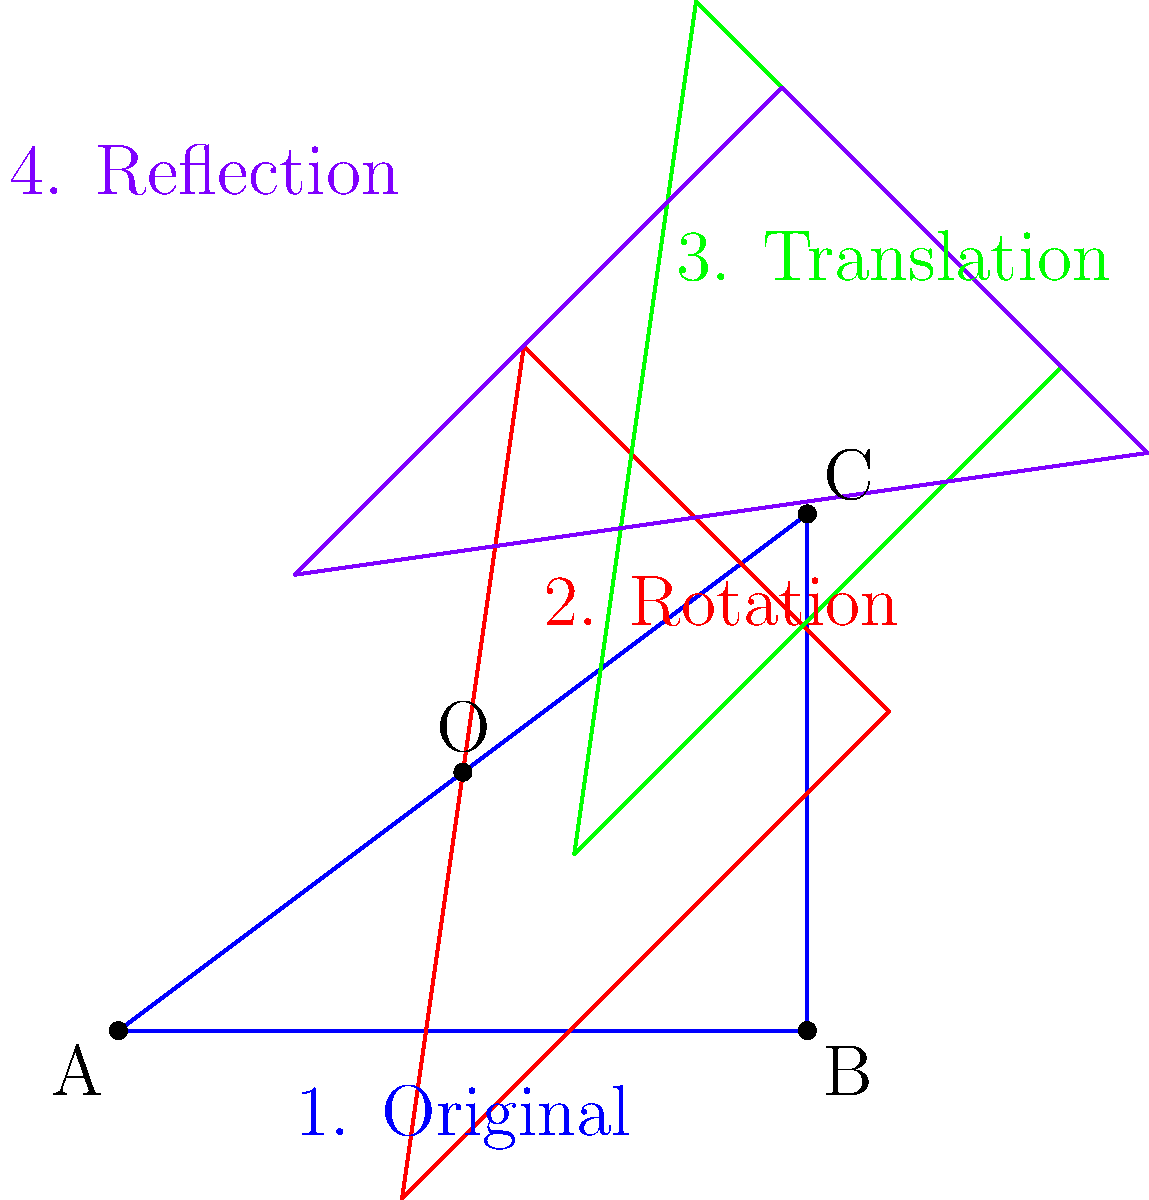Given a triangle ABC with vertices A(0,0), B(4,0), and C(4,3), the following transformations are applied in order:
1. Rotation by 45° counterclockwise around point O(2,1.5)
2. Translation by vector (1,2)
3. Reflection across the line y = x

What are the coordinates of vertex C after all transformations have been applied? Let's break this down step-by-step:

1. Rotation:
   The rotation matrix for 45° counterclockwise is:
   $$R = \begin{bmatrix} \cos 45° & -\sin 45° \\ \sin 45° & \cos 45° \end{bmatrix} = \begin{bmatrix} \frac{\sqrt{2}}{2} & -\frac{\sqrt{2}}{2} \\ \frac{\sqrt{2}}{2} & \frac{\sqrt{2}}{2} \end{bmatrix}$$
   
   First, translate C to origin by subtracting O: (4-2, 3-1.5) = (2, 1.5)
   Apply rotation: $$\begin{bmatrix} \frac{\sqrt{2}}{2} & -\frac{\sqrt{2}}{2} \\ \frac{\sqrt{2}}{2} & \frac{\sqrt{2}}{2} \end{bmatrix} \begin{bmatrix} 2 \\ 1.5 \end{bmatrix} = \begin{bmatrix} 0.35355 \\ 2.47487 \end{bmatrix}$$
   Translate back: (0.35355 + 2, 2.47487 + 1.5) = (2.35355, 3.97487)

2. Translation:
   Add the translation vector: (2.35355 + 1, 3.97487 + 2) = (3.35355, 5.97487)

3. Reflection:
   For reflection across y = x, swap x and y coordinates: (5.97487, 3.35355)

Therefore, the final coordinates of vertex C are approximately (5.97, 3.35).
Answer: (5.97, 3.35) 